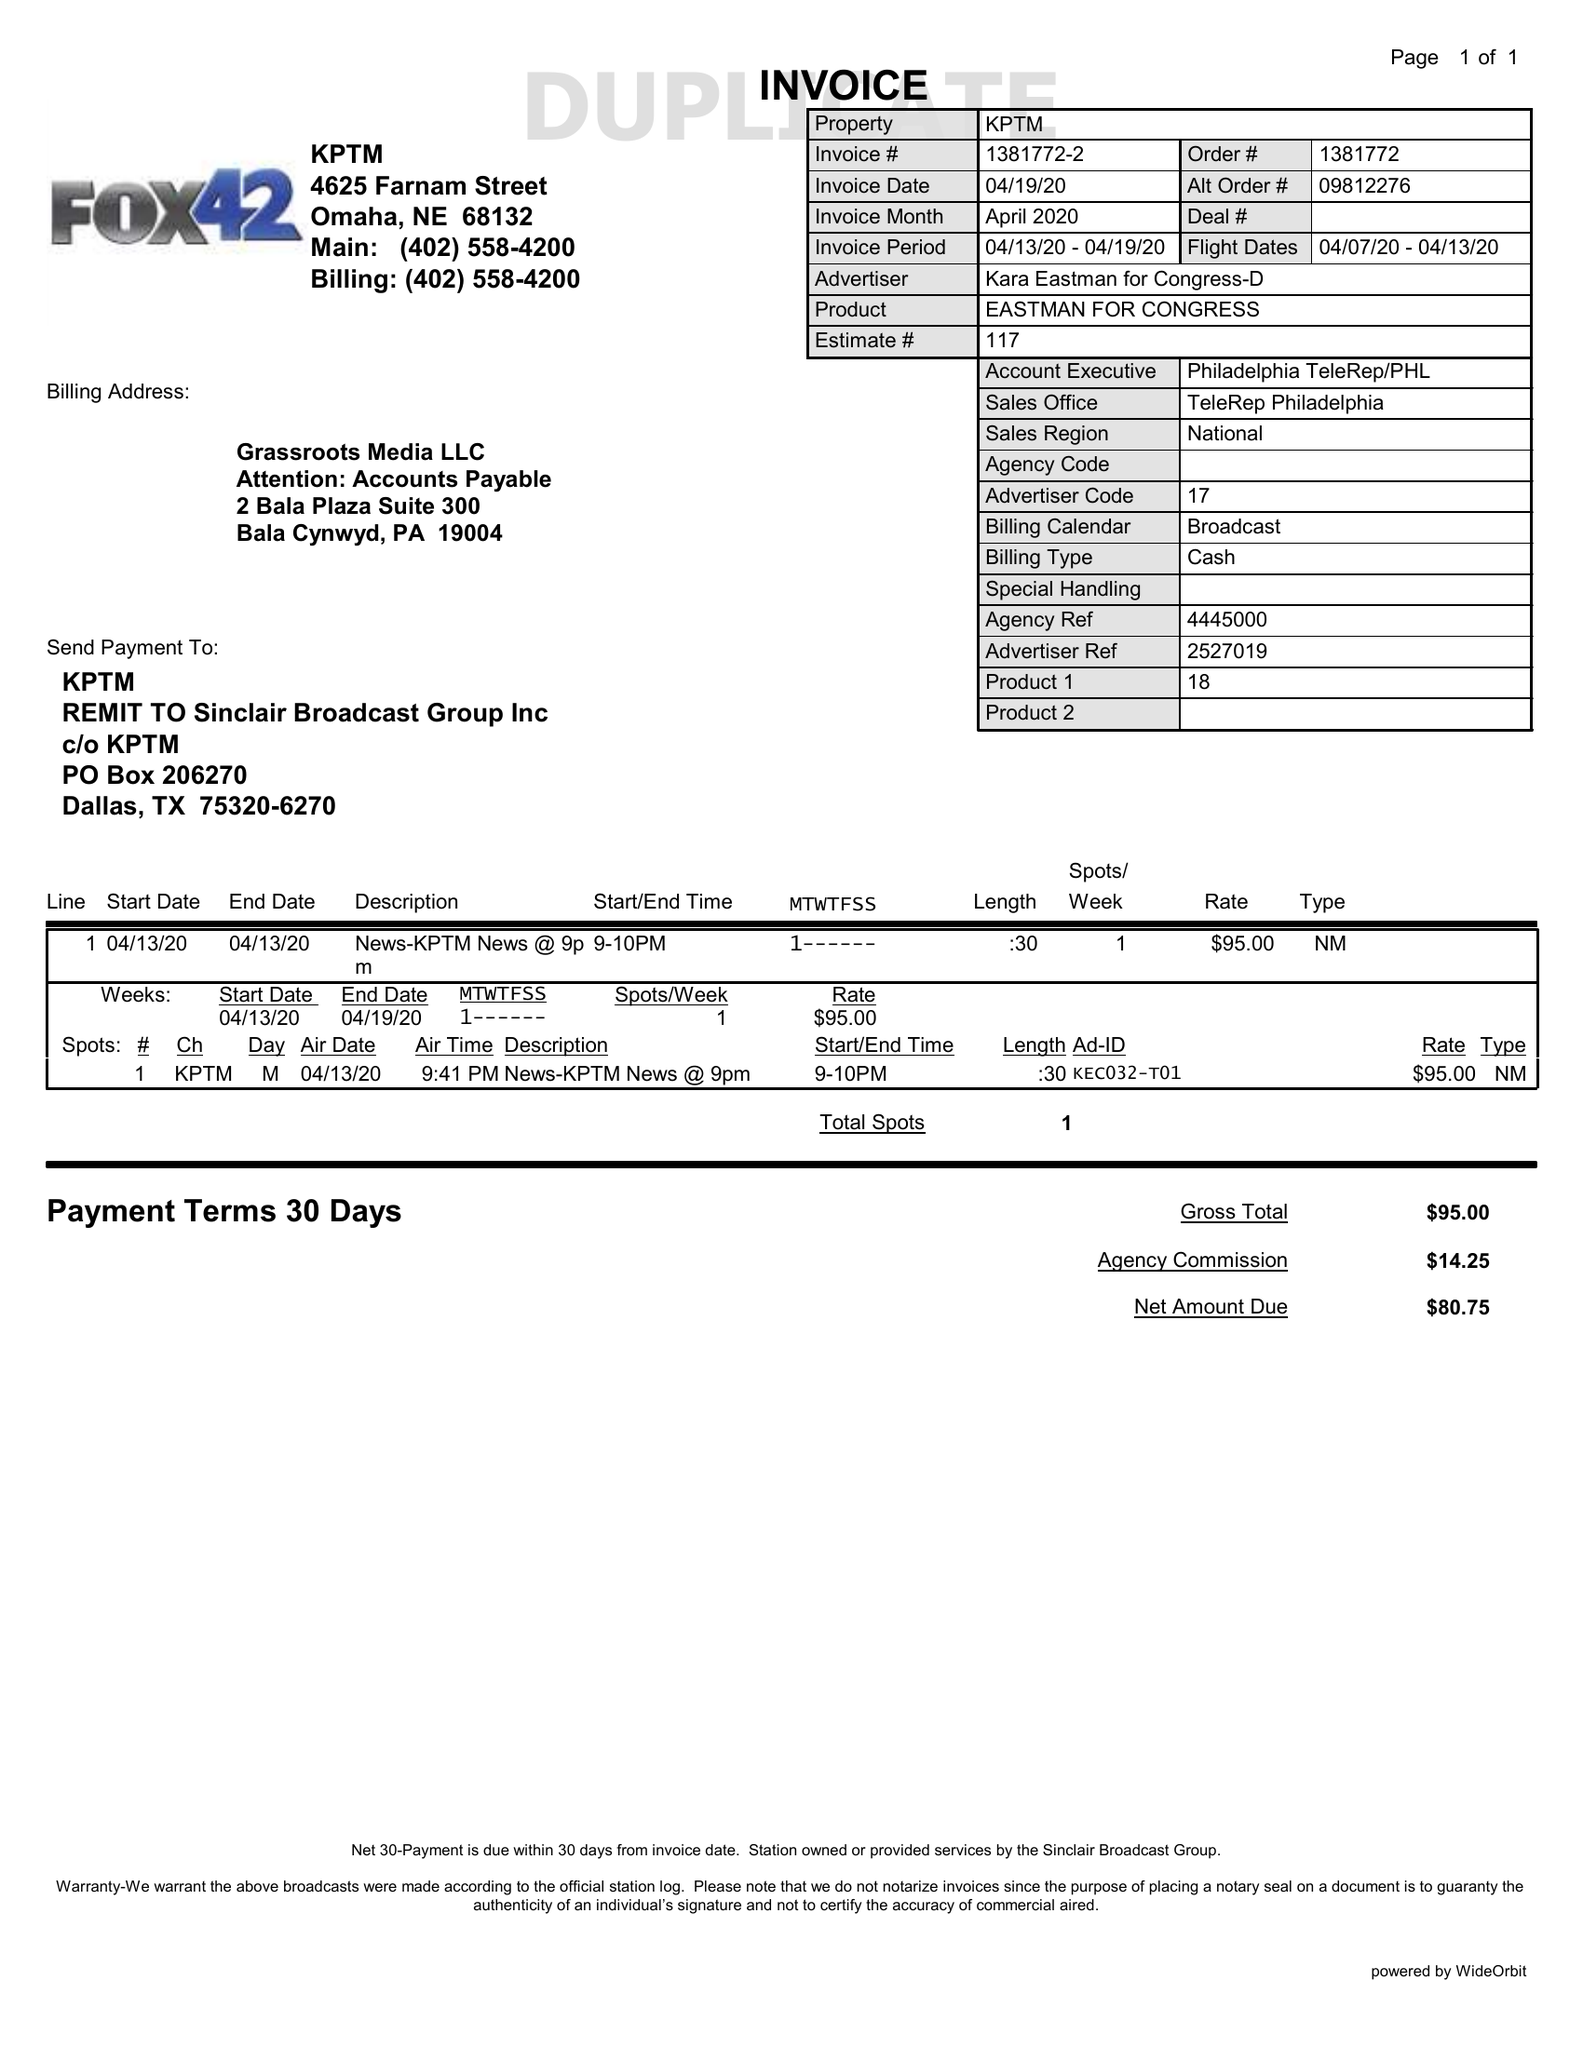What is the value for the flight_from?
Answer the question using a single word or phrase. 04/07/20 